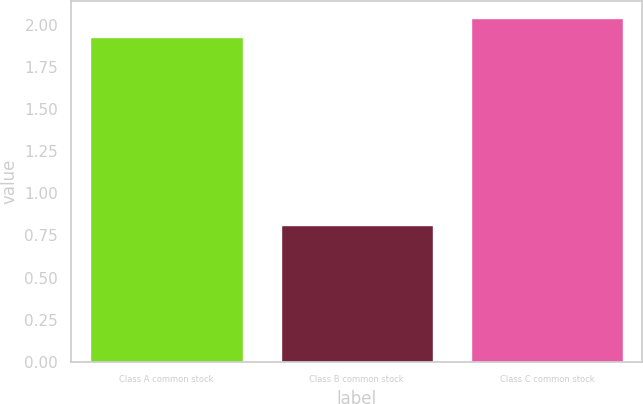<chart> <loc_0><loc_0><loc_500><loc_500><bar_chart><fcel>Class A common stock<fcel>Class B common stock<fcel>Class C common stock<nl><fcel>1.93<fcel>0.81<fcel>2.04<nl></chart> 